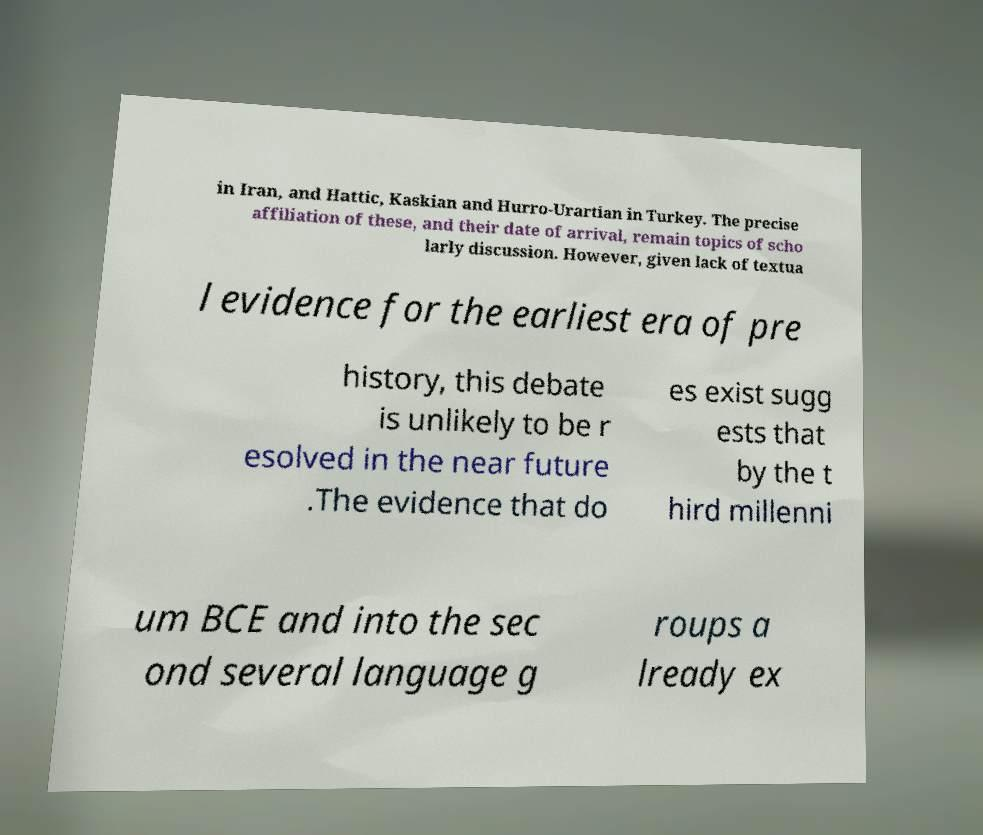I need the written content from this picture converted into text. Can you do that? in Iran, and Hattic, Kaskian and Hurro-Urartian in Turkey. The precise affiliation of these, and their date of arrival, remain topics of scho larly discussion. However, given lack of textua l evidence for the earliest era of pre history, this debate is unlikely to be r esolved in the near future .The evidence that do es exist sugg ests that by the t hird millenni um BCE and into the sec ond several language g roups a lready ex 